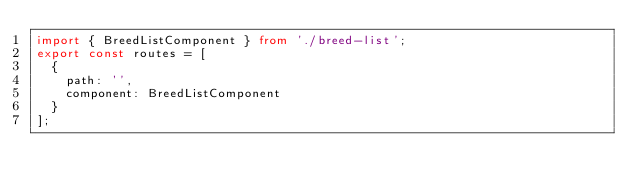<code> <loc_0><loc_0><loc_500><loc_500><_TypeScript_>import { BreedListComponent } from './breed-list';
export const routes = [
  {
    path: '',
    component: BreedListComponent
  }
];
</code> 